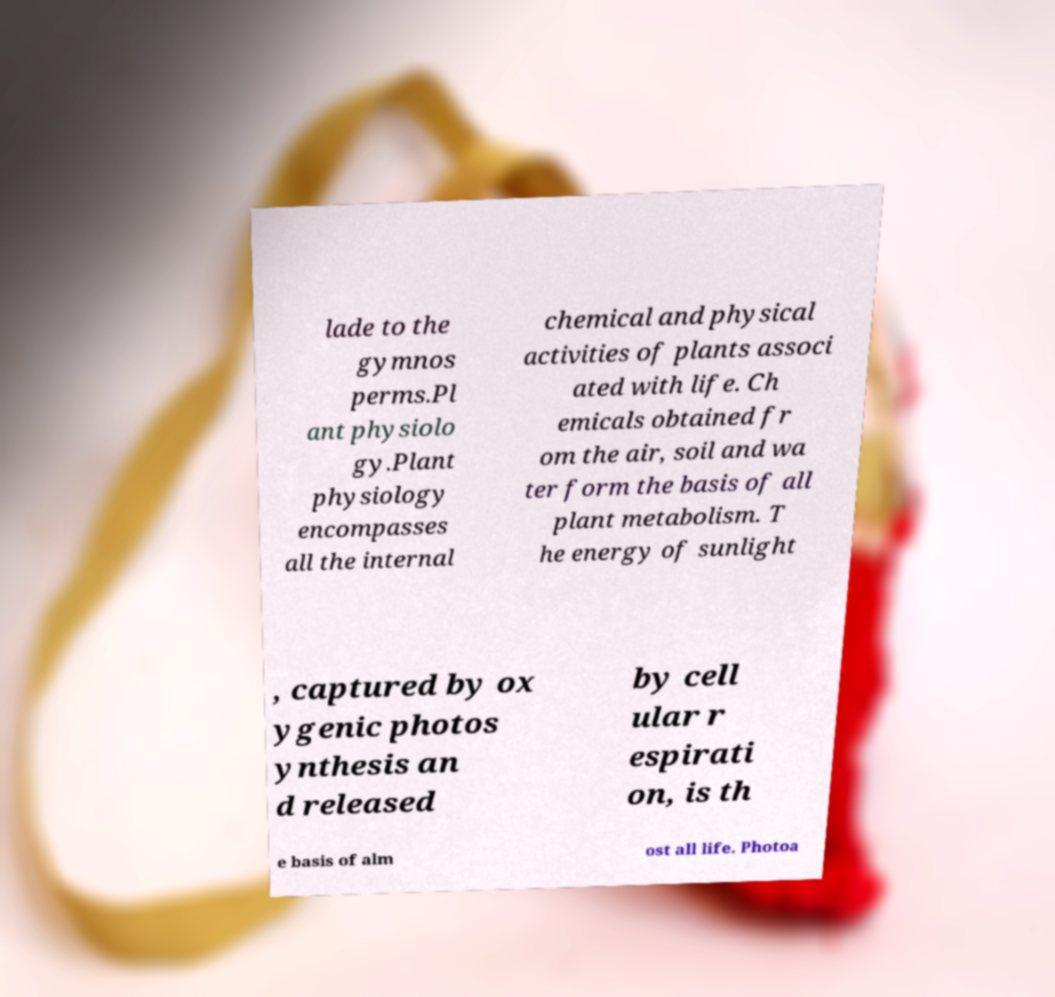What messages or text are displayed in this image? I need them in a readable, typed format. lade to the gymnos perms.Pl ant physiolo gy.Plant physiology encompasses all the internal chemical and physical activities of plants associ ated with life. Ch emicals obtained fr om the air, soil and wa ter form the basis of all plant metabolism. T he energy of sunlight , captured by ox ygenic photos ynthesis an d released by cell ular r espirati on, is th e basis of alm ost all life. Photoa 